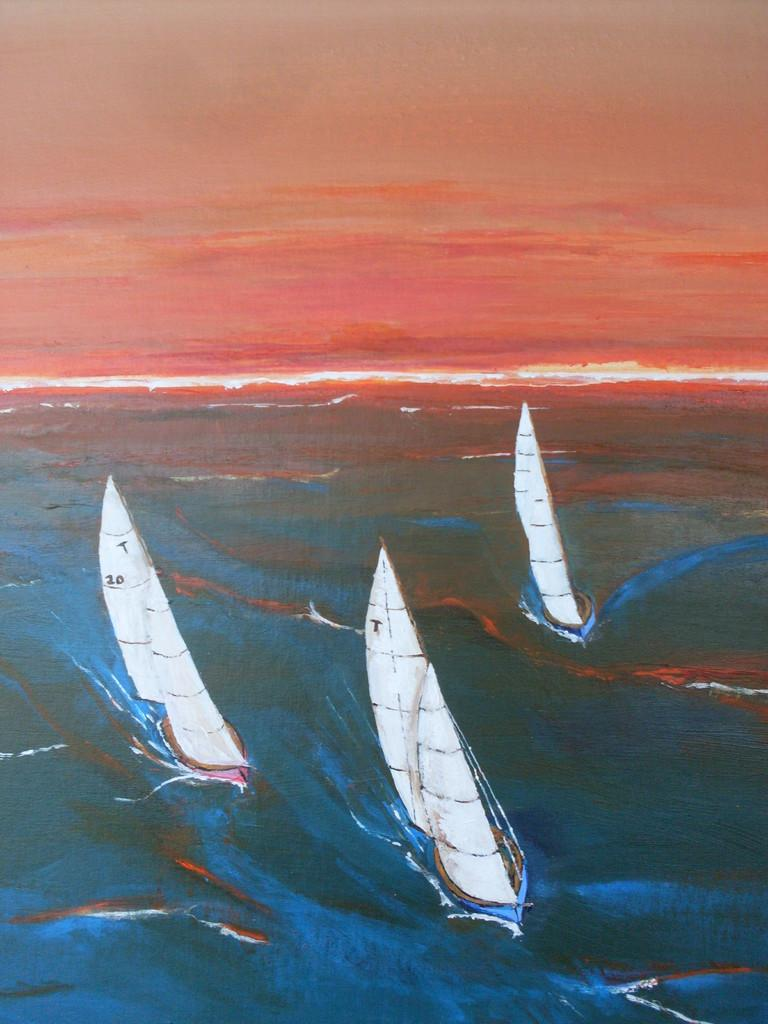<image>
Share a concise interpretation of the image provided. a boat that has the letter T at the top of it 